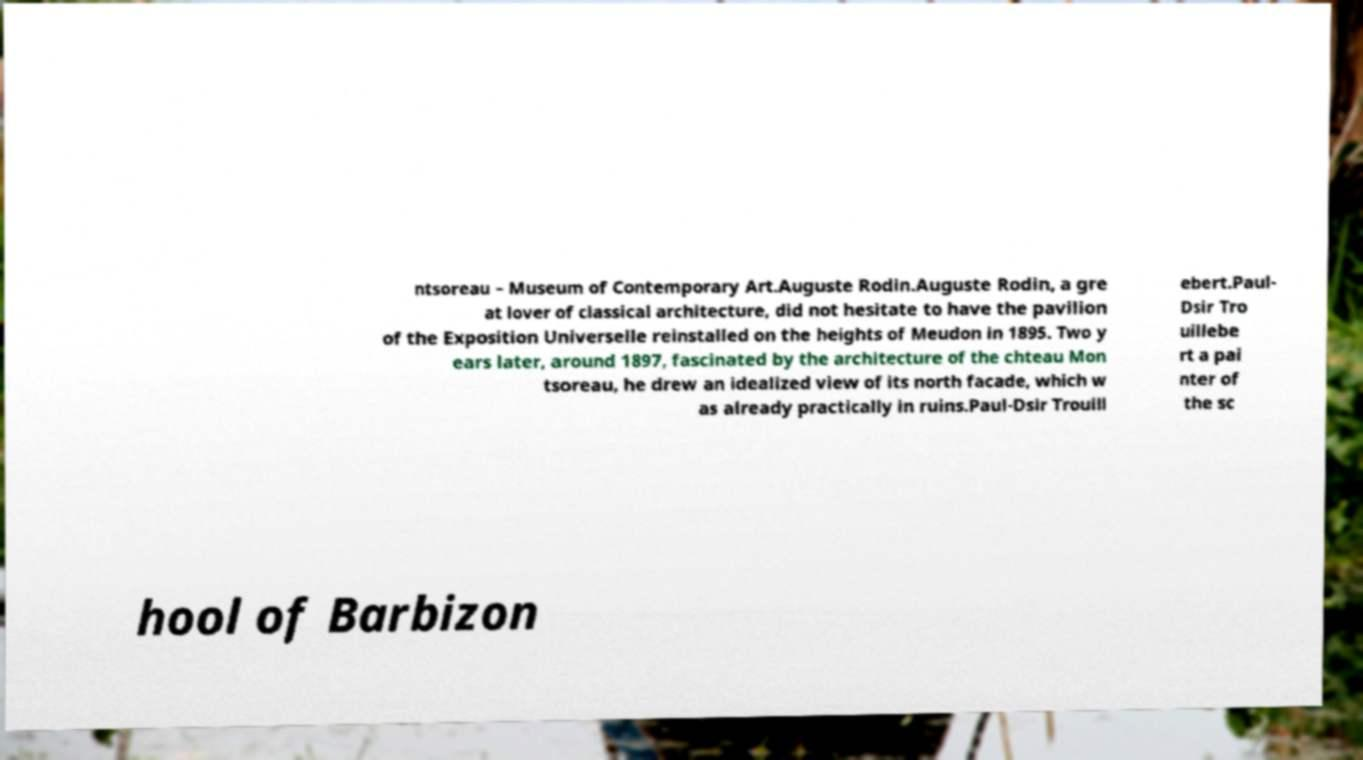Can you accurately transcribe the text from the provided image for me? ntsoreau – Museum of Contemporary Art.Auguste Rodin.Auguste Rodin, a gre at lover of classical architecture, did not hesitate to have the pavilion of the Exposition Universelle reinstalled on the heights of Meudon in 1895. Two y ears later, around 1897, fascinated by the architecture of the chteau Mon tsoreau, he drew an idealized view of its north facade, which w as already practically in ruins.Paul-Dsir Trouill ebert.Paul- Dsir Tro uillebe rt a pai nter of the sc hool of Barbizon 